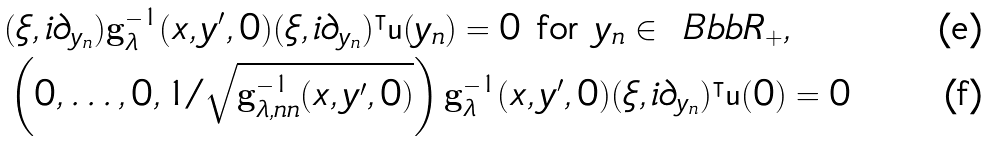Convert formula to latex. <formula><loc_0><loc_0><loc_500><loc_500>& ( \xi , i \partial _ { y _ { n } } ) \mathbf g _ { \lambda } ^ { - 1 } ( x , y ^ { \prime } , 0 ) ( \xi , i \partial _ { y _ { n } } ) ^ { \intercal } \mathsf u ( y _ { n } ) = 0 \text { for } y _ { n } \in \ B b b R _ { + } , \\ & \left ( 0 , \dots , 0 , 1 / \sqrt { \mathbf g ^ { - 1 } _ { \lambda , n n } ( x , y ^ { \prime } , 0 ) } \right ) \mathbf g ^ { - 1 } _ { \lambda } ( x , y ^ { \prime } , 0 ) ( \xi , i \partial _ { y _ { n } } ) ^ { \intercal } \mathsf u ( 0 ) = 0</formula> 